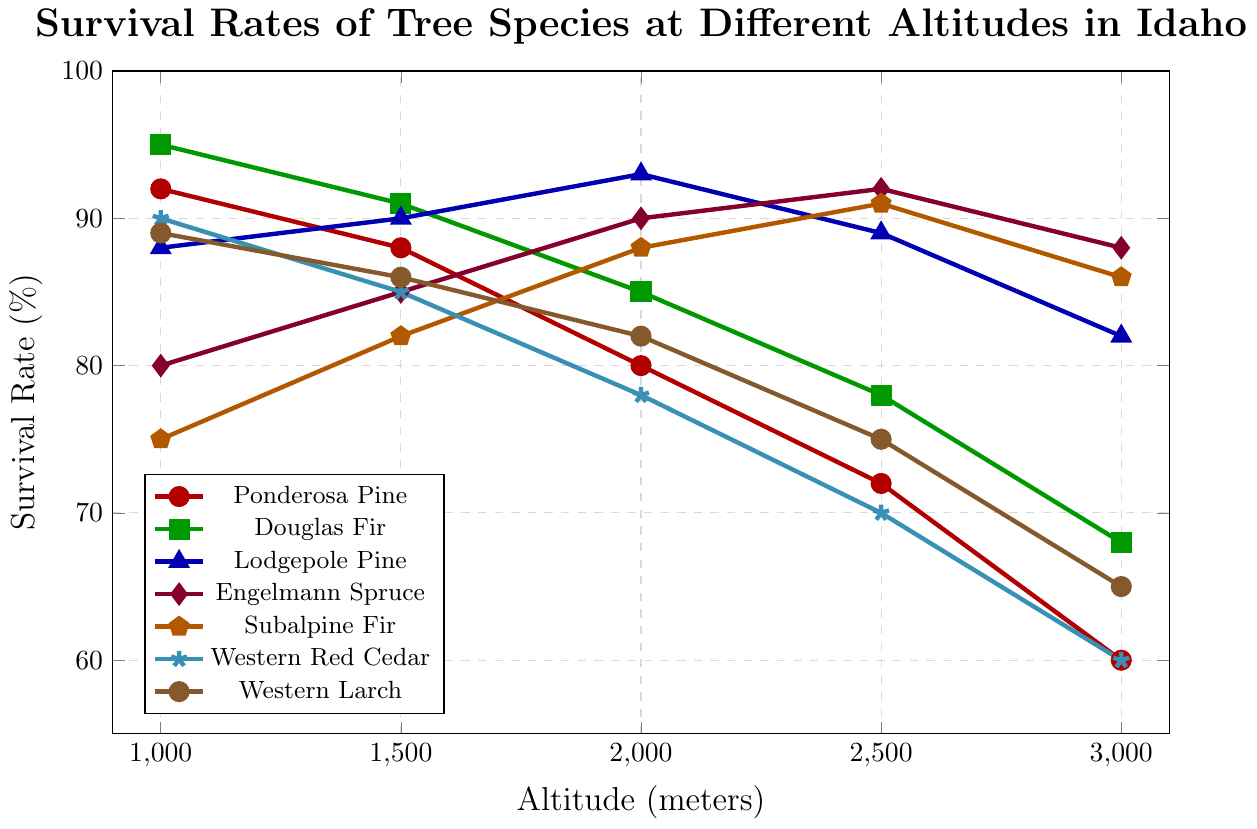Which tree species has the highest survival rate at 1000 meters? Check the dots at the 1000 meter altitude mark and compare their y-axis (survival rate) values.
Answer: Douglas Fir How do the survival rates of Ponderosa Pine and Western Red Cedar compare at 2500 meters? Find the points for Ponderosa Pine and Western Red Cedar at 2500 meters and compare their y-values. Ponderosa Pine has a survival rate of 72%, while Western Red Cedar has a survival rate of 70%.
Answer: Ponderosa Pine has a higher survival rate What is the difference between the highest and lowest survival rates observed at 3000 meters? Identify the highest and lowest survival rates at 3000 meters: Engelmann Spruce has the highest (88%) and Western Red Cedar has the lowest (60%). Calculate the difference: 88% - 60%.
Answer: 28% Which species shows an increasing trend in survival rate as altitude increases? Look for a line whose y-values (survival rate) increase with increasing x-values (altitude). Engelmann Spruce and Subalpine Fir show this trend.
Answer: Engelmann Spruce, Subalpine Fir What is the average survival rate of Douglas Fir across all altitudes? Sum the survival rates of Douglas Fir at all altitudes and divide by the number of data points: (95 + 91 + 85 + 78 + 68)/5 = 83.4%.
Answer: 83.4% Which species has the sharpest decrease in survival rate from 1000 meters to 3000 meters? Calculate the difference in survival rates at 1000 and 3000 meters for each species. Western Red Cedar has the sharpest decrease: 90% - 60% = 30%.
Answer: Western Red Cedar At which altitude does Lodgepole Pine have the highest survival rate? Find the altitude where Lodgepole Pine's survival rate is highest by checking the y-values of its points. Lodgepole Pine has the highest survival rate at 2000 meters (93%).
Answer: 2000 meters How do the survival rates of Douglas Fir and Engelmann Spruce compare at 1500 meters? Check the points for Douglas Fir and Engelmann Spruce at 1500 meters and compare their y-values. Douglas Fir has a survival rate of 91%, while Engelmann Spruce has 85%.
Answer: Douglas Fir has a higher survival rate What trend do you observe in the survival rates of Ponderosa Pine as the altitude increases? Follow the dots representing Ponderosa Pine from 1000 to 3000 meters. The survival rate consistently decreases as the altitude increases.
Answer: Decreasing trend Which species has the highest survival rate at 2500 meters? Compare the survival rates of all species at 2500 meters. Engelmann Spruce has the highest survival rate at 92%.
Answer: Engelmann Spruce 